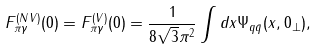Convert formula to latex. <formula><loc_0><loc_0><loc_500><loc_500>F ^ { ( N V ) } _ { \pi \gamma } ( 0 ) = F ^ { ( V ) } _ { \pi \gamma } ( 0 ) = \frac { 1 } { 8 \sqrt { 3 } \pi ^ { 2 } } \int d x \Psi _ { q \bar { q } } ( x , 0 _ { \perp } ) ,</formula> 